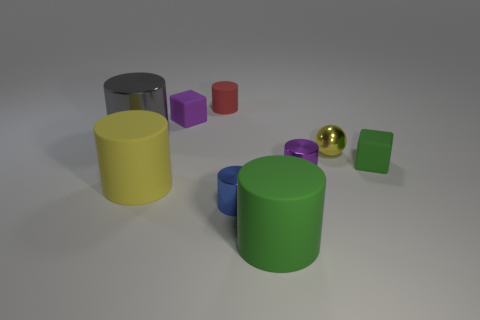There is a big gray metallic thing; what number of big green matte cylinders are in front of it?
Ensure brevity in your answer.  1. What number of other things are the same color as the small shiny ball?
Keep it short and to the point. 1. Are there fewer small matte cubes to the right of the purple cylinder than big shiny cylinders that are in front of the yellow rubber object?
Offer a very short reply. No. What number of objects are small objects that are behind the large metal cylinder or gray metal cylinders?
Your answer should be very brief. 3. Is the size of the blue cylinder the same as the green object that is to the left of the purple cylinder?
Your response must be concise. No. What is the size of the yellow rubber thing that is the same shape as the blue object?
Offer a terse response. Large. What number of metal cylinders are on the right side of the yellow matte thing that is right of the gray metal object to the left of the yellow ball?
Keep it short and to the point. 2. What number of balls are either small green things or red objects?
Offer a terse response. 0. There is a big cylinder behind the cube that is on the right side of the green cylinder that is right of the tiny blue shiny object; what is its color?
Keep it short and to the point. Gray. What number of other objects are there of the same size as the yellow cylinder?
Provide a short and direct response. 2. 